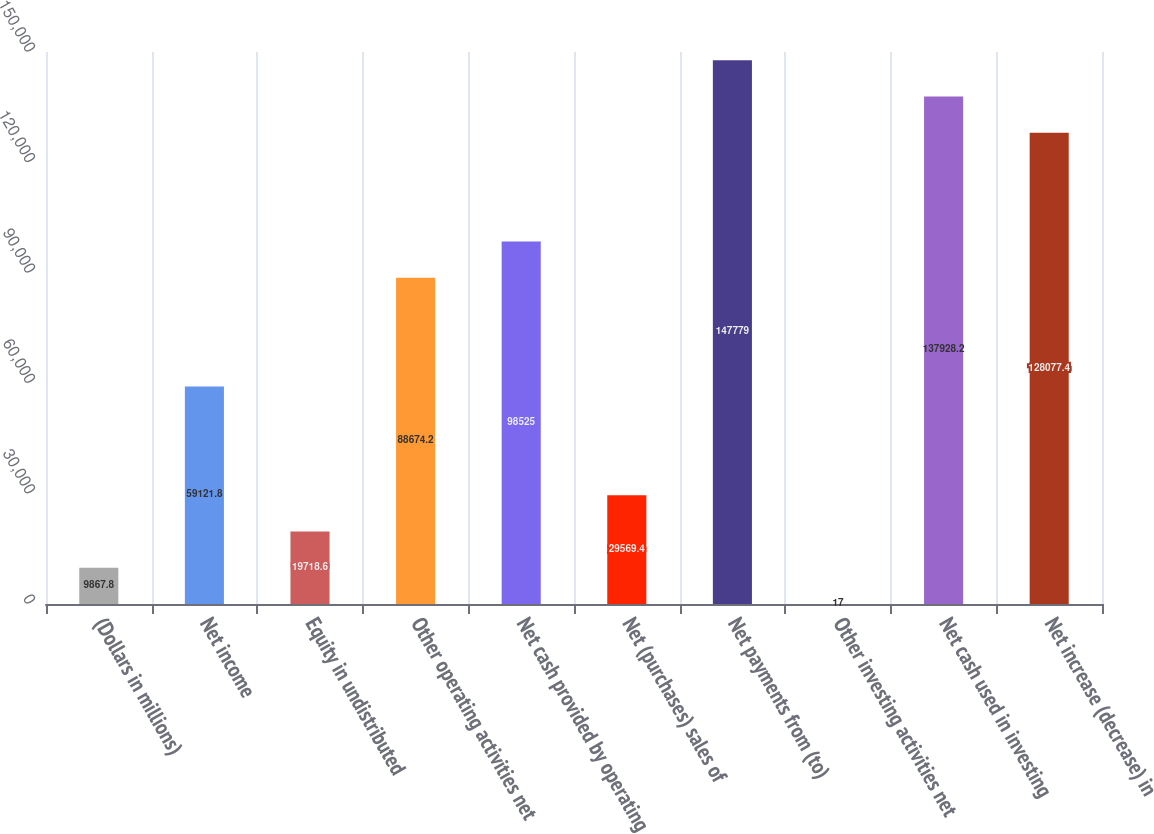Convert chart to OTSL. <chart><loc_0><loc_0><loc_500><loc_500><bar_chart><fcel>(Dollars in millions)<fcel>Net income<fcel>Equity in undistributed<fcel>Other operating activities net<fcel>Net cash provided by operating<fcel>Net (purchases) sales of<fcel>Net payments from (to)<fcel>Other investing activities net<fcel>Net cash used in investing<fcel>Net increase (decrease) in<nl><fcel>9867.8<fcel>59121.8<fcel>19718.6<fcel>88674.2<fcel>98525<fcel>29569.4<fcel>147779<fcel>17<fcel>137928<fcel>128077<nl></chart> 